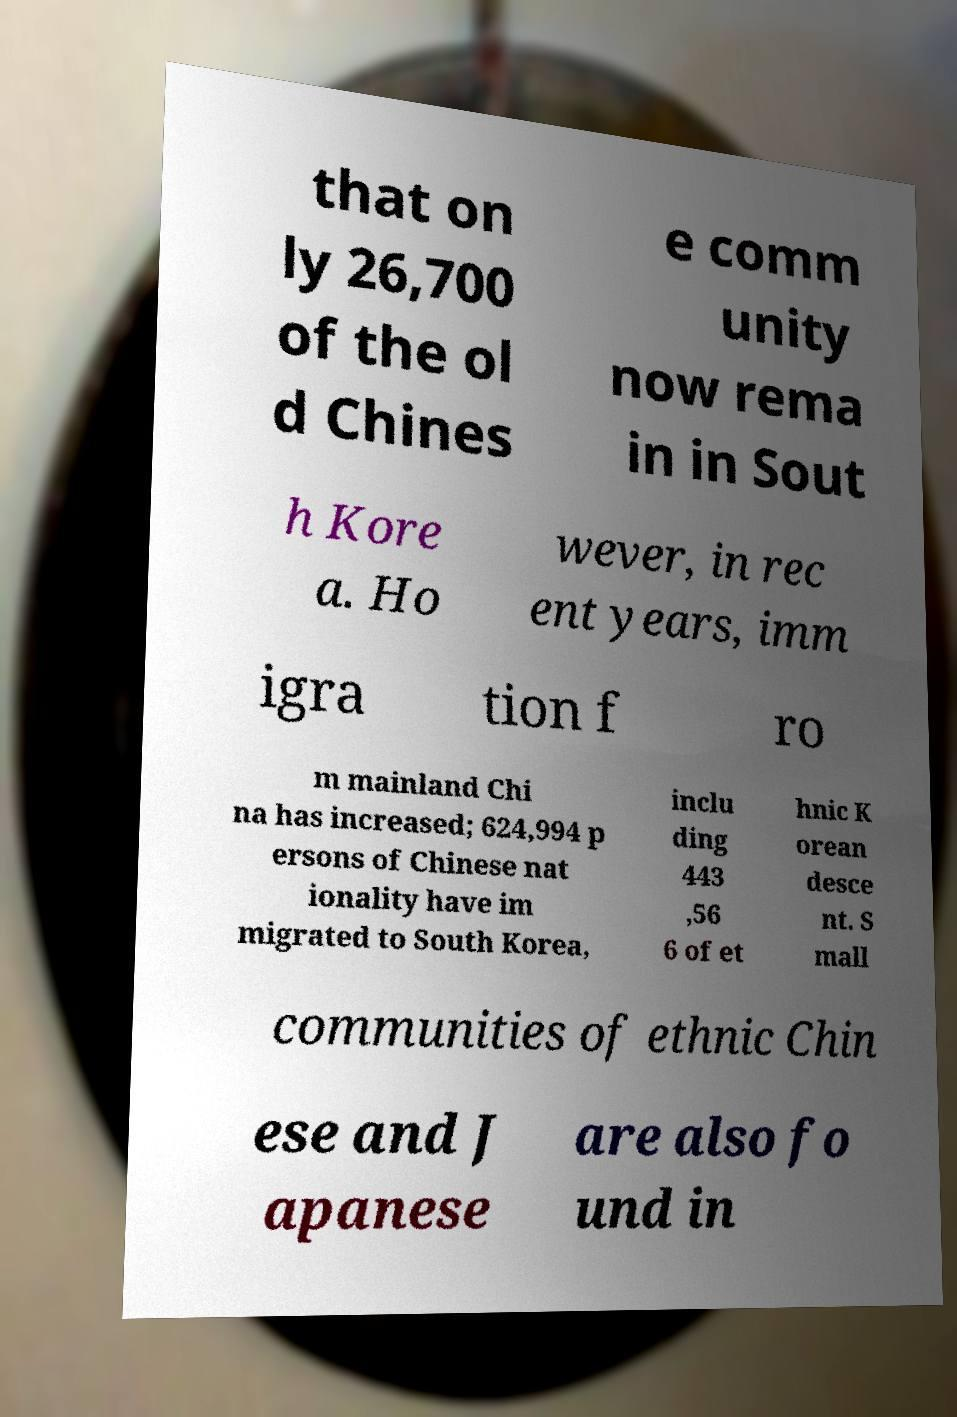I need the written content from this picture converted into text. Can you do that? that on ly 26,700 of the ol d Chines e comm unity now rema in in Sout h Kore a. Ho wever, in rec ent years, imm igra tion f ro m mainland Chi na has increased; 624,994 p ersons of Chinese nat ionality have im migrated to South Korea, inclu ding 443 ,56 6 of et hnic K orean desce nt. S mall communities of ethnic Chin ese and J apanese are also fo und in 